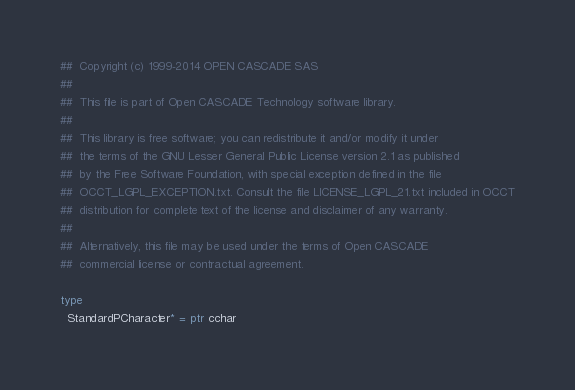Convert code to text. <code><loc_0><loc_0><loc_500><loc_500><_Nim_>##  Copyright (c) 1999-2014 OPEN CASCADE SAS
##
##  This file is part of Open CASCADE Technology software library.
##
##  This library is free software; you can redistribute it and/or modify it under
##  the terms of the GNU Lesser General Public License version 2.1 as published
##  by the Free Software Foundation, with special exception defined in the file
##  OCCT_LGPL_EXCEPTION.txt. Consult the file LICENSE_LGPL_21.txt included in OCCT
##  distribution for complete text of the license and disclaimer of any warranty.
##
##  Alternatively, this file may be used under the terms of Open CASCADE
##  commercial license or contractual agreement.

type
  StandardPCharacter* = ptr cchar
</code> 